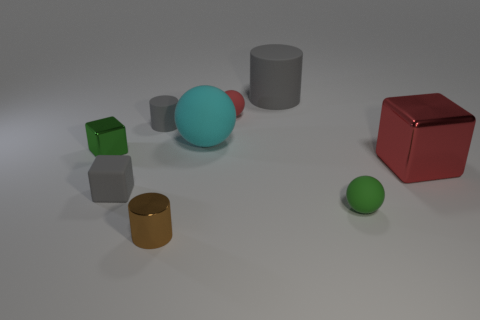Add 1 big red metallic spheres. How many objects exist? 10 Subtract all blocks. How many objects are left? 6 Add 4 small green blocks. How many small green blocks are left? 5 Add 2 big cyan rubber spheres. How many big cyan rubber spheres exist? 3 Subtract 0 blue blocks. How many objects are left? 9 Subtract all small gray matte cylinders. Subtract all tiny blue shiny cylinders. How many objects are left? 8 